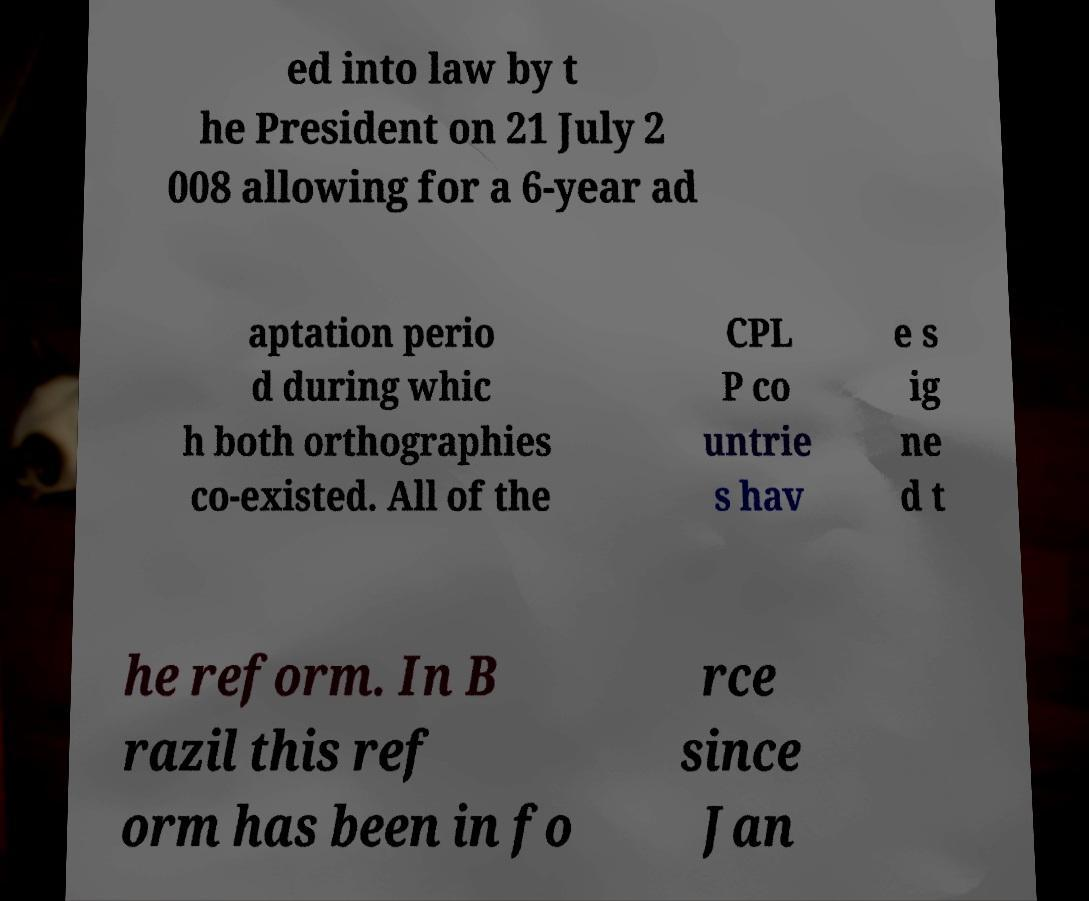Please identify and transcribe the text found in this image. ed into law by t he President on 21 July 2 008 allowing for a 6-year ad aptation perio d during whic h both orthographies co-existed. All of the CPL P co untrie s hav e s ig ne d t he reform. In B razil this ref orm has been in fo rce since Jan 